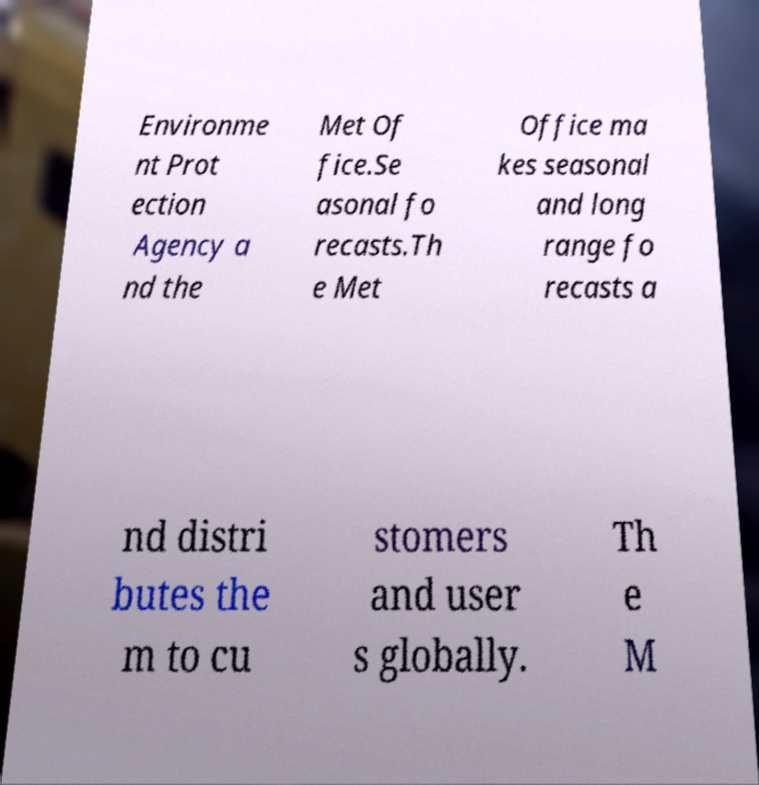I need the written content from this picture converted into text. Can you do that? Environme nt Prot ection Agency a nd the Met Of fice.Se asonal fo recasts.Th e Met Office ma kes seasonal and long range fo recasts a nd distri butes the m to cu stomers and user s globally. Th e M 